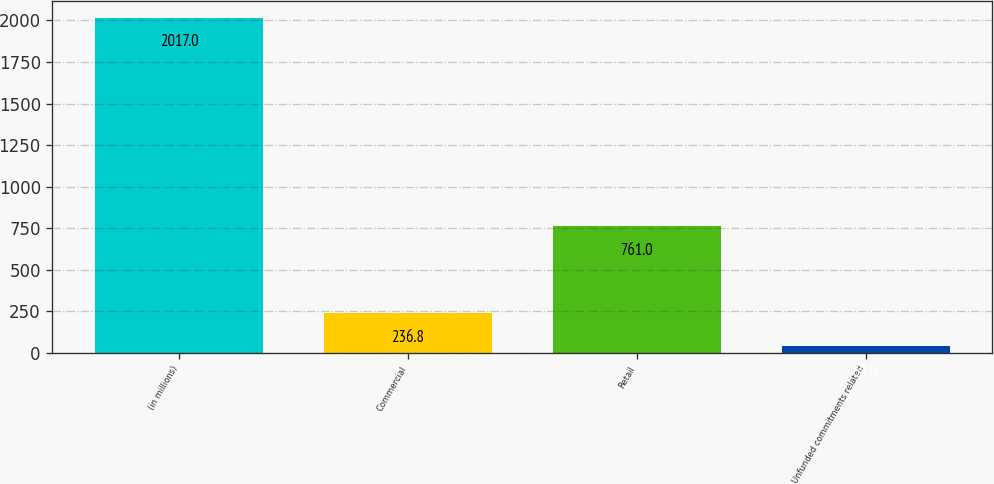Convert chart. <chart><loc_0><loc_0><loc_500><loc_500><bar_chart><fcel>(in millions)<fcel>Commercial<fcel>Retail<fcel>Unfunded commitments related<nl><fcel>2017<fcel>236.8<fcel>761<fcel>39<nl></chart> 